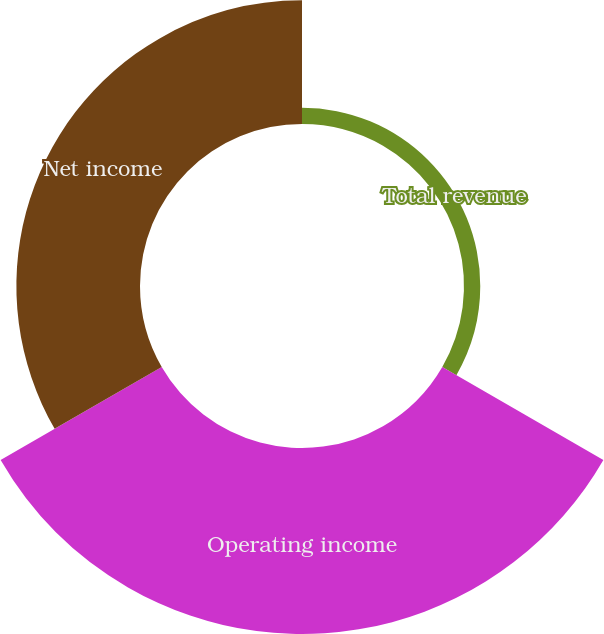Convert chart to OTSL. <chart><loc_0><loc_0><loc_500><loc_500><pie_chart><fcel>Total revenue<fcel>Operating income<fcel>Net income<nl><fcel>4.99%<fcel>57.08%<fcel>37.94%<nl></chart> 